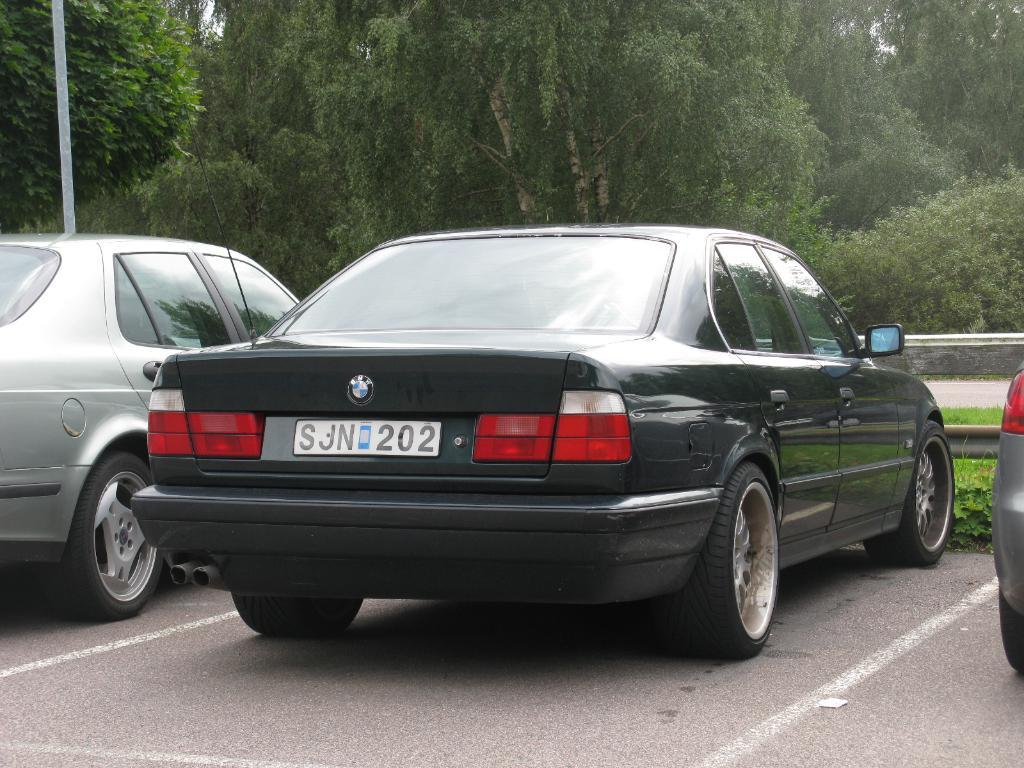What type of vehicles can be seen on the road in the image? There are cars on the road in the image. What other elements can be seen in the image besides the cars? There are plants and a pole visible in the image. What can be seen in the background of the image? There are trees and a wall in the background of the image. What type of teaching method is being used in the image? There is no teaching or classroom setting present in the image. Can you locate the key in the image? There is no key visible in the image. 